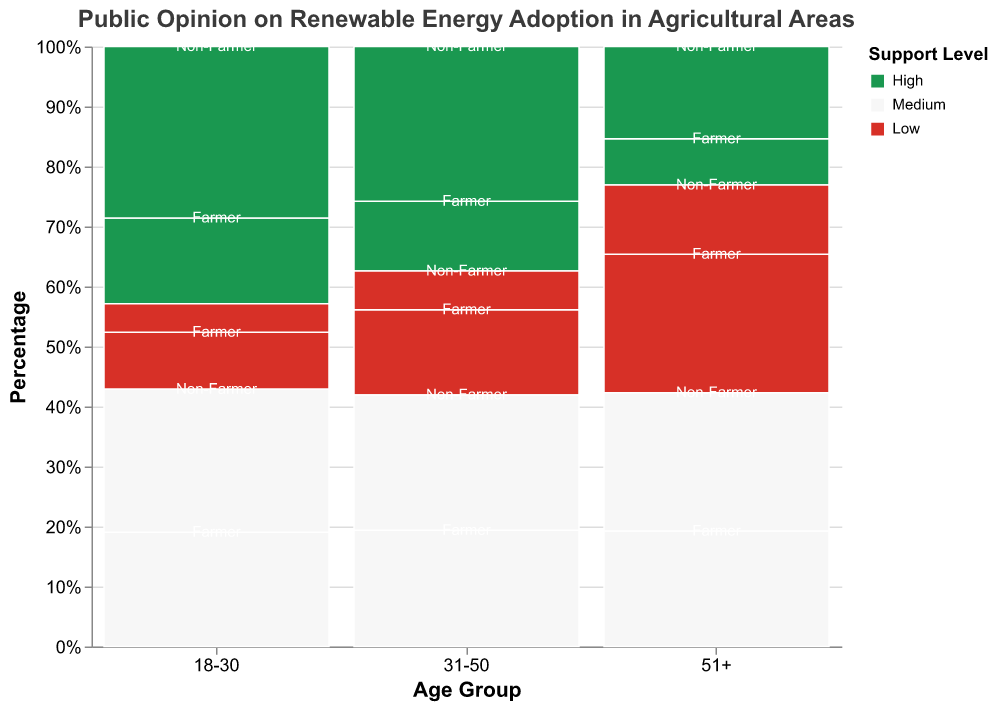What is the title of the plot? The title is displayed at the top of the plot.
Answer: Public Opinion on Renewable Energy Adoption in Agricultural Areas Which age group has the highest percentage of support for high renewable energy adoption among non-farmers? Look at the sections labeled "High" within each age group and observe the height of the non-farmer sections.
Answer: 31-50 What is the most common support level among farmers aged 31-50? Observe the "Farmer" sections within the "31-50" group and identify the largest segment by height.
Answer: Medium Which group has a higher proportion of low support for renewable energy adoption, farmers aged 51+ or non-farmers aged 51+? Compare the height of the "Low" support sections in the "51+" age group for both farmers and non-farmers.
Answer: Farmers aged 51+ How does the level of high support among non-farmers aged 18-30 compare to farmers aged 18-30? Compare the height of the "High" support sections for non-farmers and farmers within the "18-30" age group.
Answer: Non-farmers have a higher level of high support than farmers What percentage of the 18-30 age group are medium supporters among farmers? Sum up the total count for the "18-30" farmers, calculate how many are medium supporters, and determine the percentage.
Answer: 44.4% What is the trend of high support for renewable energy adoption across different age groups among non-farmers? Observe the "High" support sections for non-farmers across different age groups and describe the trend.
Answer: Decreases with age In the 51+ age group, which occupation shows a larger percentage of medium support for renewable energy adoption? Compare the height of the "Medium" support sections in the "51+" age group for both occupations.
Answer: Non-farmers Which support level has the least representation among non-farmers in the 18-30 age group? Look for the smallest segment within the "18-30" non-farmer sections.
Answer: Low What is the difference in the percentage of low support between farmers aged 31-50 and non-farmers aged 31-50? Calculate the percentage of low support for both groups and find the difference.
Answer: 20% 